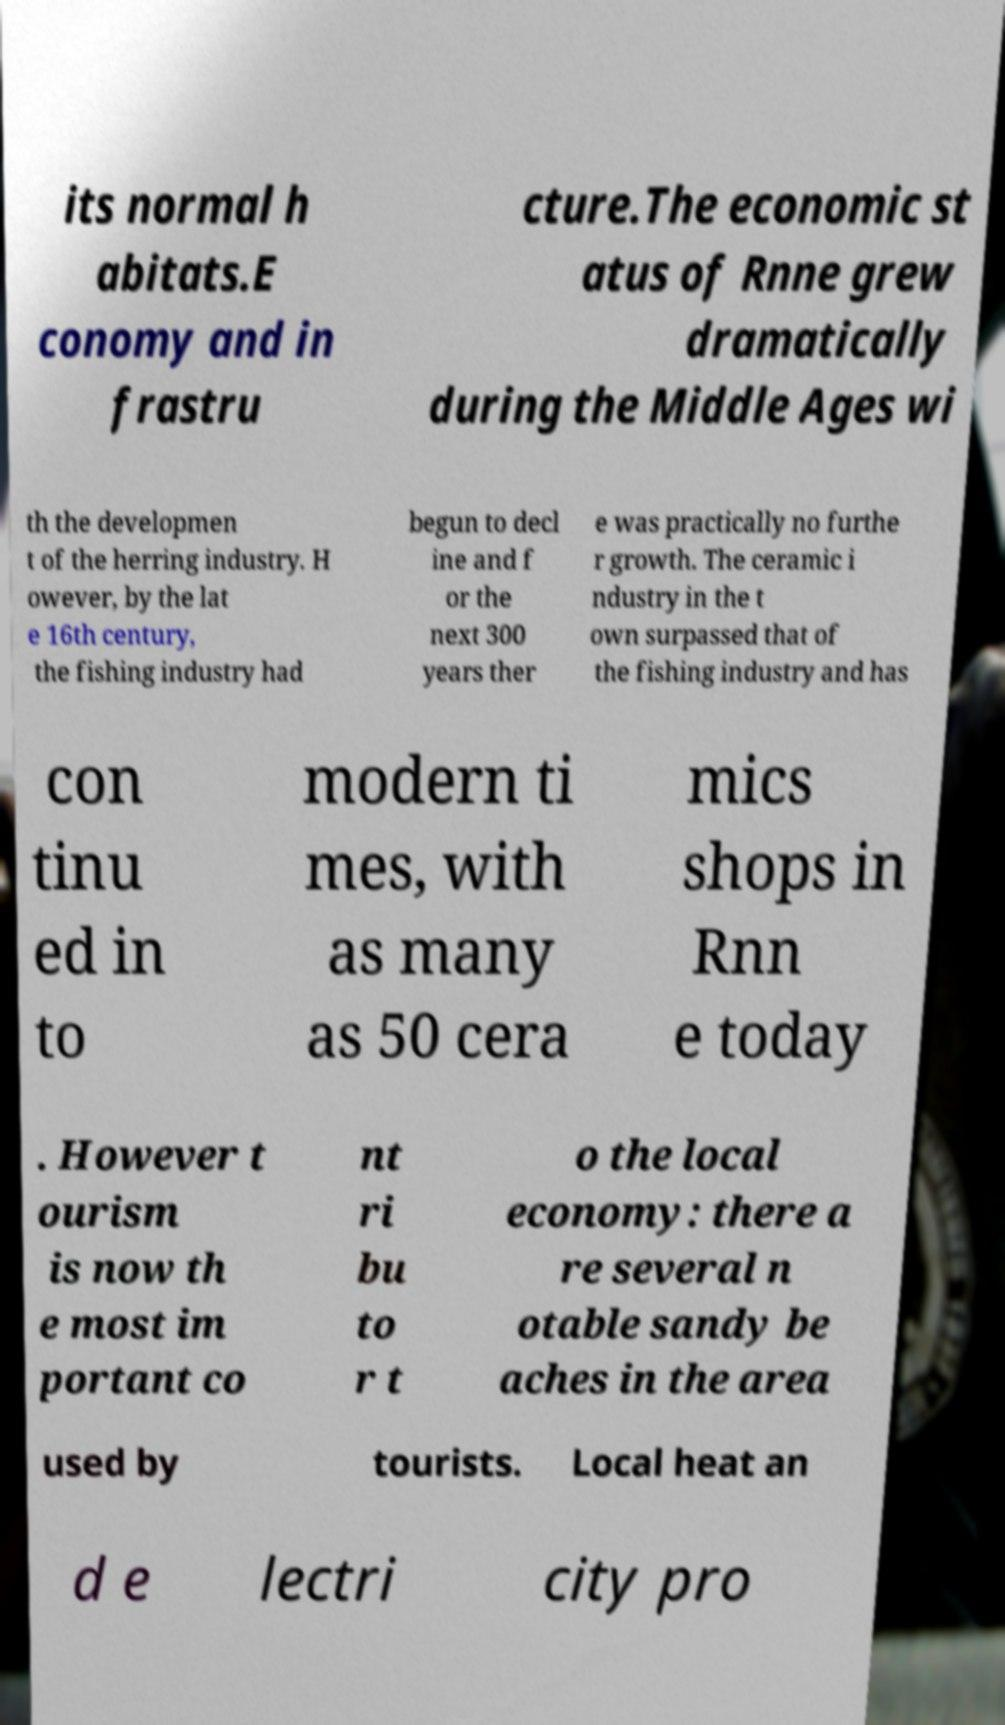There's text embedded in this image that I need extracted. Can you transcribe it verbatim? its normal h abitats.E conomy and in frastru cture.The economic st atus of Rnne grew dramatically during the Middle Ages wi th the developmen t of the herring industry. H owever, by the lat e 16th century, the fishing industry had begun to decl ine and f or the next 300 years ther e was practically no furthe r growth. The ceramic i ndustry in the t own surpassed that of the fishing industry and has con tinu ed in to modern ti mes, with as many as 50 cera mics shops in Rnn e today . However t ourism is now th e most im portant co nt ri bu to r t o the local economy: there a re several n otable sandy be aches in the area used by tourists. Local heat an d e lectri city pro 